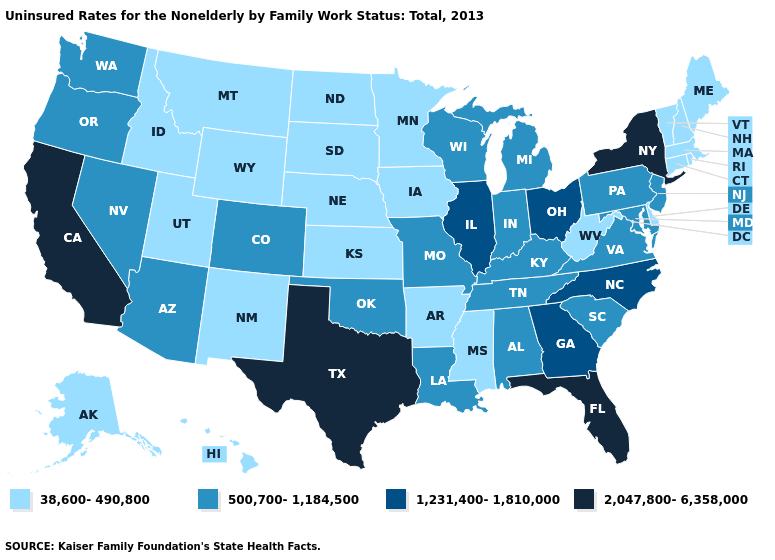Name the states that have a value in the range 2,047,800-6,358,000?
Give a very brief answer. California, Florida, New York, Texas. Which states have the lowest value in the West?
Quick response, please. Alaska, Hawaii, Idaho, Montana, New Mexico, Utah, Wyoming. Name the states that have a value in the range 1,231,400-1,810,000?
Give a very brief answer. Georgia, Illinois, North Carolina, Ohio. What is the value of Oklahoma?
Quick response, please. 500,700-1,184,500. Does Texas have the highest value in the USA?
Keep it brief. Yes. Does Arkansas have the same value as Michigan?
Be succinct. No. Does Missouri have a lower value than North Carolina?
Answer briefly. Yes. What is the highest value in states that border Mississippi?
Keep it brief. 500,700-1,184,500. What is the highest value in the USA?
Concise answer only. 2,047,800-6,358,000. What is the highest value in the West ?
Quick response, please. 2,047,800-6,358,000. Name the states that have a value in the range 500,700-1,184,500?
Keep it brief. Alabama, Arizona, Colorado, Indiana, Kentucky, Louisiana, Maryland, Michigan, Missouri, Nevada, New Jersey, Oklahoma, Oregon, Pennsylvania, South Carolina, Tennessee, Virginia, Washington, Wisconsin. What is the value of Mississippi?
Answer briefly. 38,600-490,800. Name the states that have a value in the range 500,700-1,184,500?
Short answer required. Alabama, Arizona, Colorado, Indiana, Kentucky, Louisiana, Maryland, Michigan, Missouri, Nevada, New Jersey, Oklahoma, Oregon, Pennsylvania, South Carolina, Tennessee, Virginia, Washington, Wisconsin. What is the value of Illinois?
Quick response, please. 1,231,400-1,810,000. 